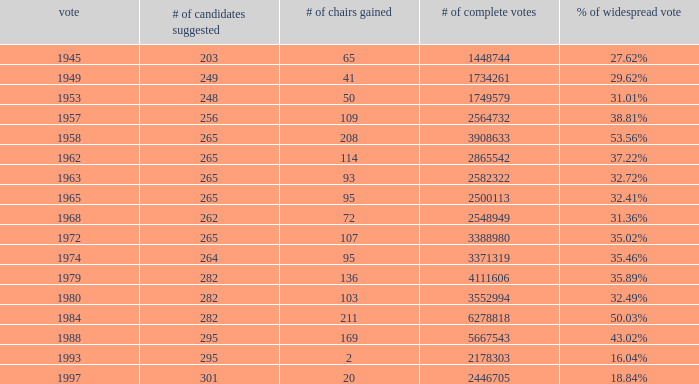What year was the election when the # of seats won was 65? 1945.0. 